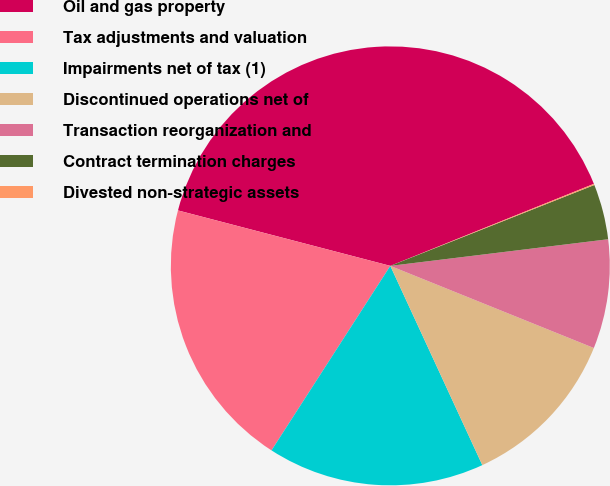Convert chart to OTSL. <chart><loc_0><loc_0><loc_500><loc_500><pie_chart><fcel>Oil and gas property<fcel>Tax adjustments and valuation<fcel>Impairments net of tax (1)<fcel>Discontinued operations net of<fcel>Transaction reorganization and<fcel>Contract termination charges<fcel>Divested non-strategic assets<nl><fcel>39.84%<fcel>19.96%<fcel>15.99%<fcel>12.01%<fcel>8.04%<fcel>4.07%<fcel>0.09%<nl></chart> 